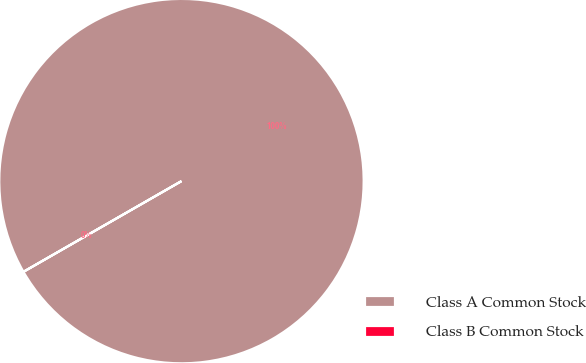<chart> <loc_0><loc_0><loc_500><loc_500><pie_chart><fcel>Class A Common Stock<fcel>Class B Common Stock<nl><fcel>100.0%<fcel>0.0%<nl></chart> 